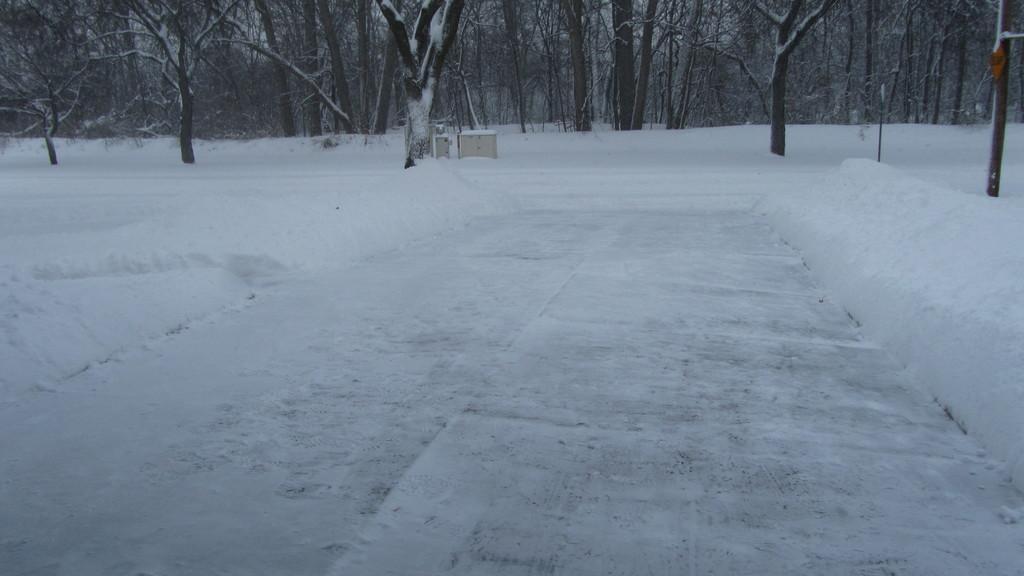Could you give a brief overview of what you see in this image? In this picture I can see some trees and snow on the ground. 